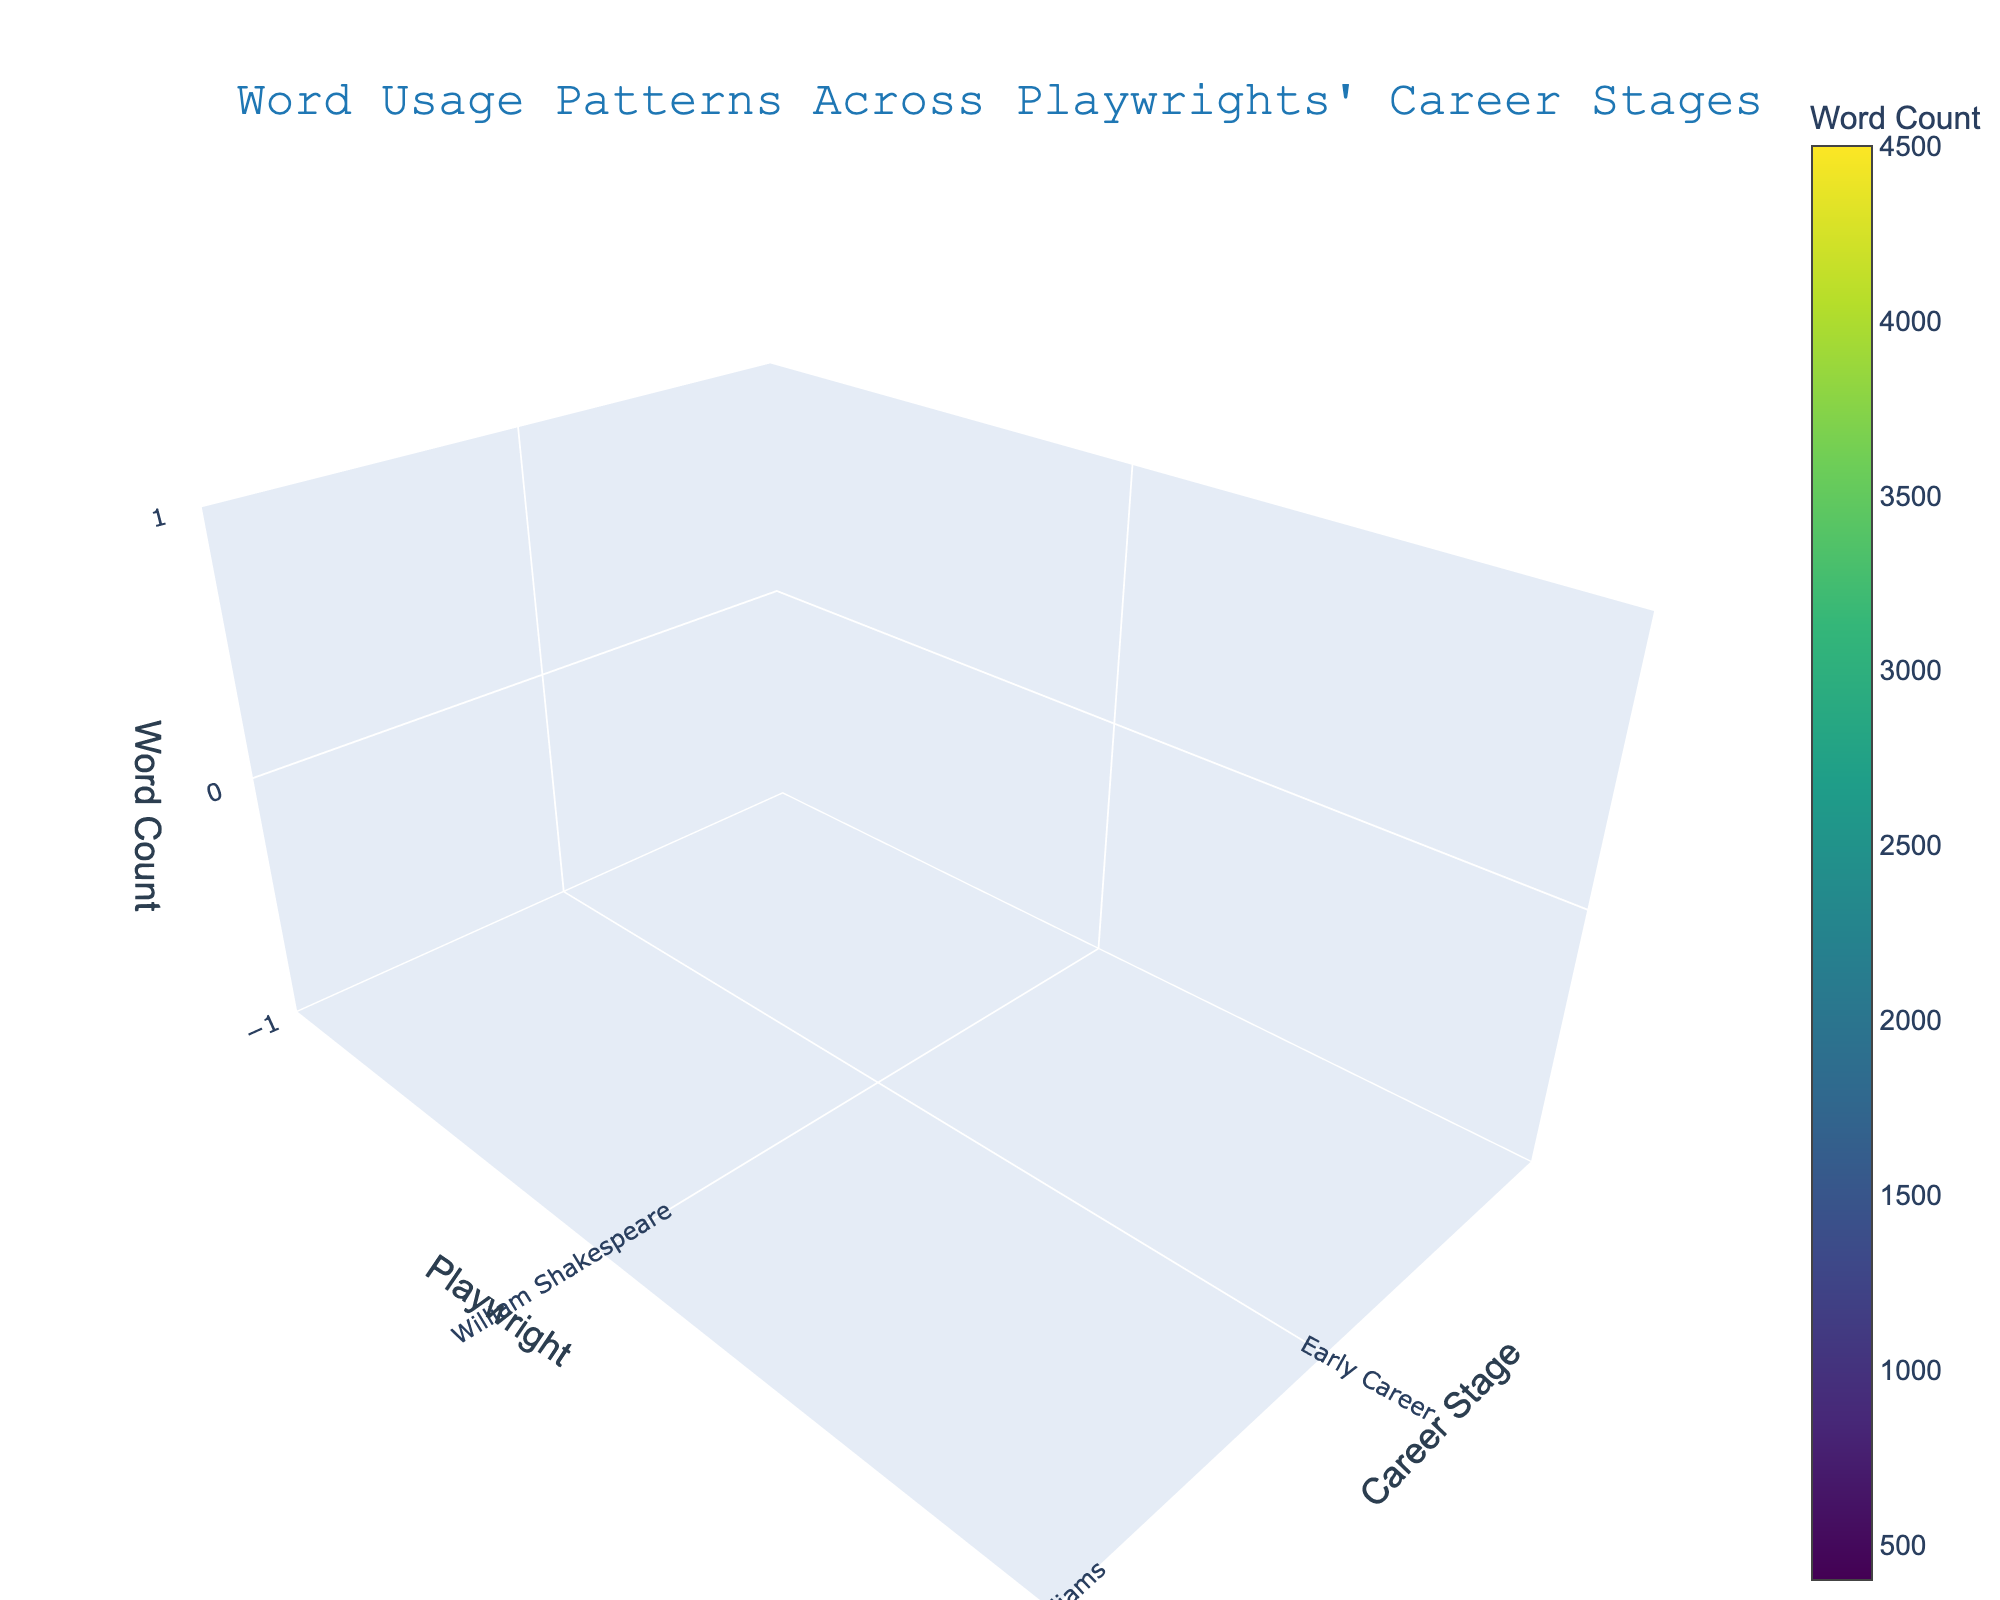What is the title of the 3D volume plot? The figure's title is usually prominently displayed at the top of the plot. Here, it's centered and reads "Word Usage Patterns Across Playwrights' Career Stages".
Answer: Word Usage Patterns Across Playwrights' Career Stages How many stages of a playwright's career are represented in the plot? The x-axis shows the career stages, labeled as 'Early Career', 'Mid Career', and 'Late Career', indicating three distinct stages.
Answer: 3 Which playwright showed the highest word usage in their Late Career stage? By observing the height of the volume bars for the Late Career stage (x-axis position corresponding to 'Late Career'), William Shakespeare's bar reaches the highest point.
Answer: William Shakespeare Between Henrik Ibsen and Anton Chekhov, who had a higher word count during their Mid Career stage? Compare the bars corresponding to the 'Mid Career' stage for both playwrights. Henrik Ibsen's bar is higher than Anton Chekhov's for this stage.
Answer: Henrik Ibsen What is the word count difference between Tennessee Williams's Early Career and Mid Career stages? Subtract the word count in the 'Early Career' stage from that in the 'Mid Career' stage for Tennessee Williams (2200 - 800).
Answer: 1400 What is the average word count for August Wilson across all three career stages? Sum the word counts for August Wilson across all stages and divide by three: (900 + 2500 + 4000) / 3.
Answer: 2467 Compare the word counts for Arthur Miller and Edward Albee in the Late Career stage. Which one is higher and by how much? Edward Albee's word count is 2800, and Arthur Miller's is 3200 in their Late Career, so Miller's is higher by (3200 - 2800).
Answer: Arthur Miller, 400 Is there any playwright whose word count consistently increases from Early to Late Career? Review the volume heights for each playwright from 'Early Career', 'Mid Career', to 'Late Career'. William Shakespeare, Tennessee Williams, Arthur Miller, Eugene O'Neill, August Wilson, Henrik Ibsen, and Anton Chekhov show a consistent increase.
Answer: Yes Which playwright has the lowest word count in their Early Career stage? The lowest bar in the 'Early Career' stage belongs to Samuel Beckett.
Answer: Samuel Beckett What is the total word count for Eugene O’Neill across all three career stages? Sum the word counts for Eugene O’Neill in 'Early Career', 'Mid Career', and 'Late Career': 700 + 2000 + 3500.
Answer: 6200 